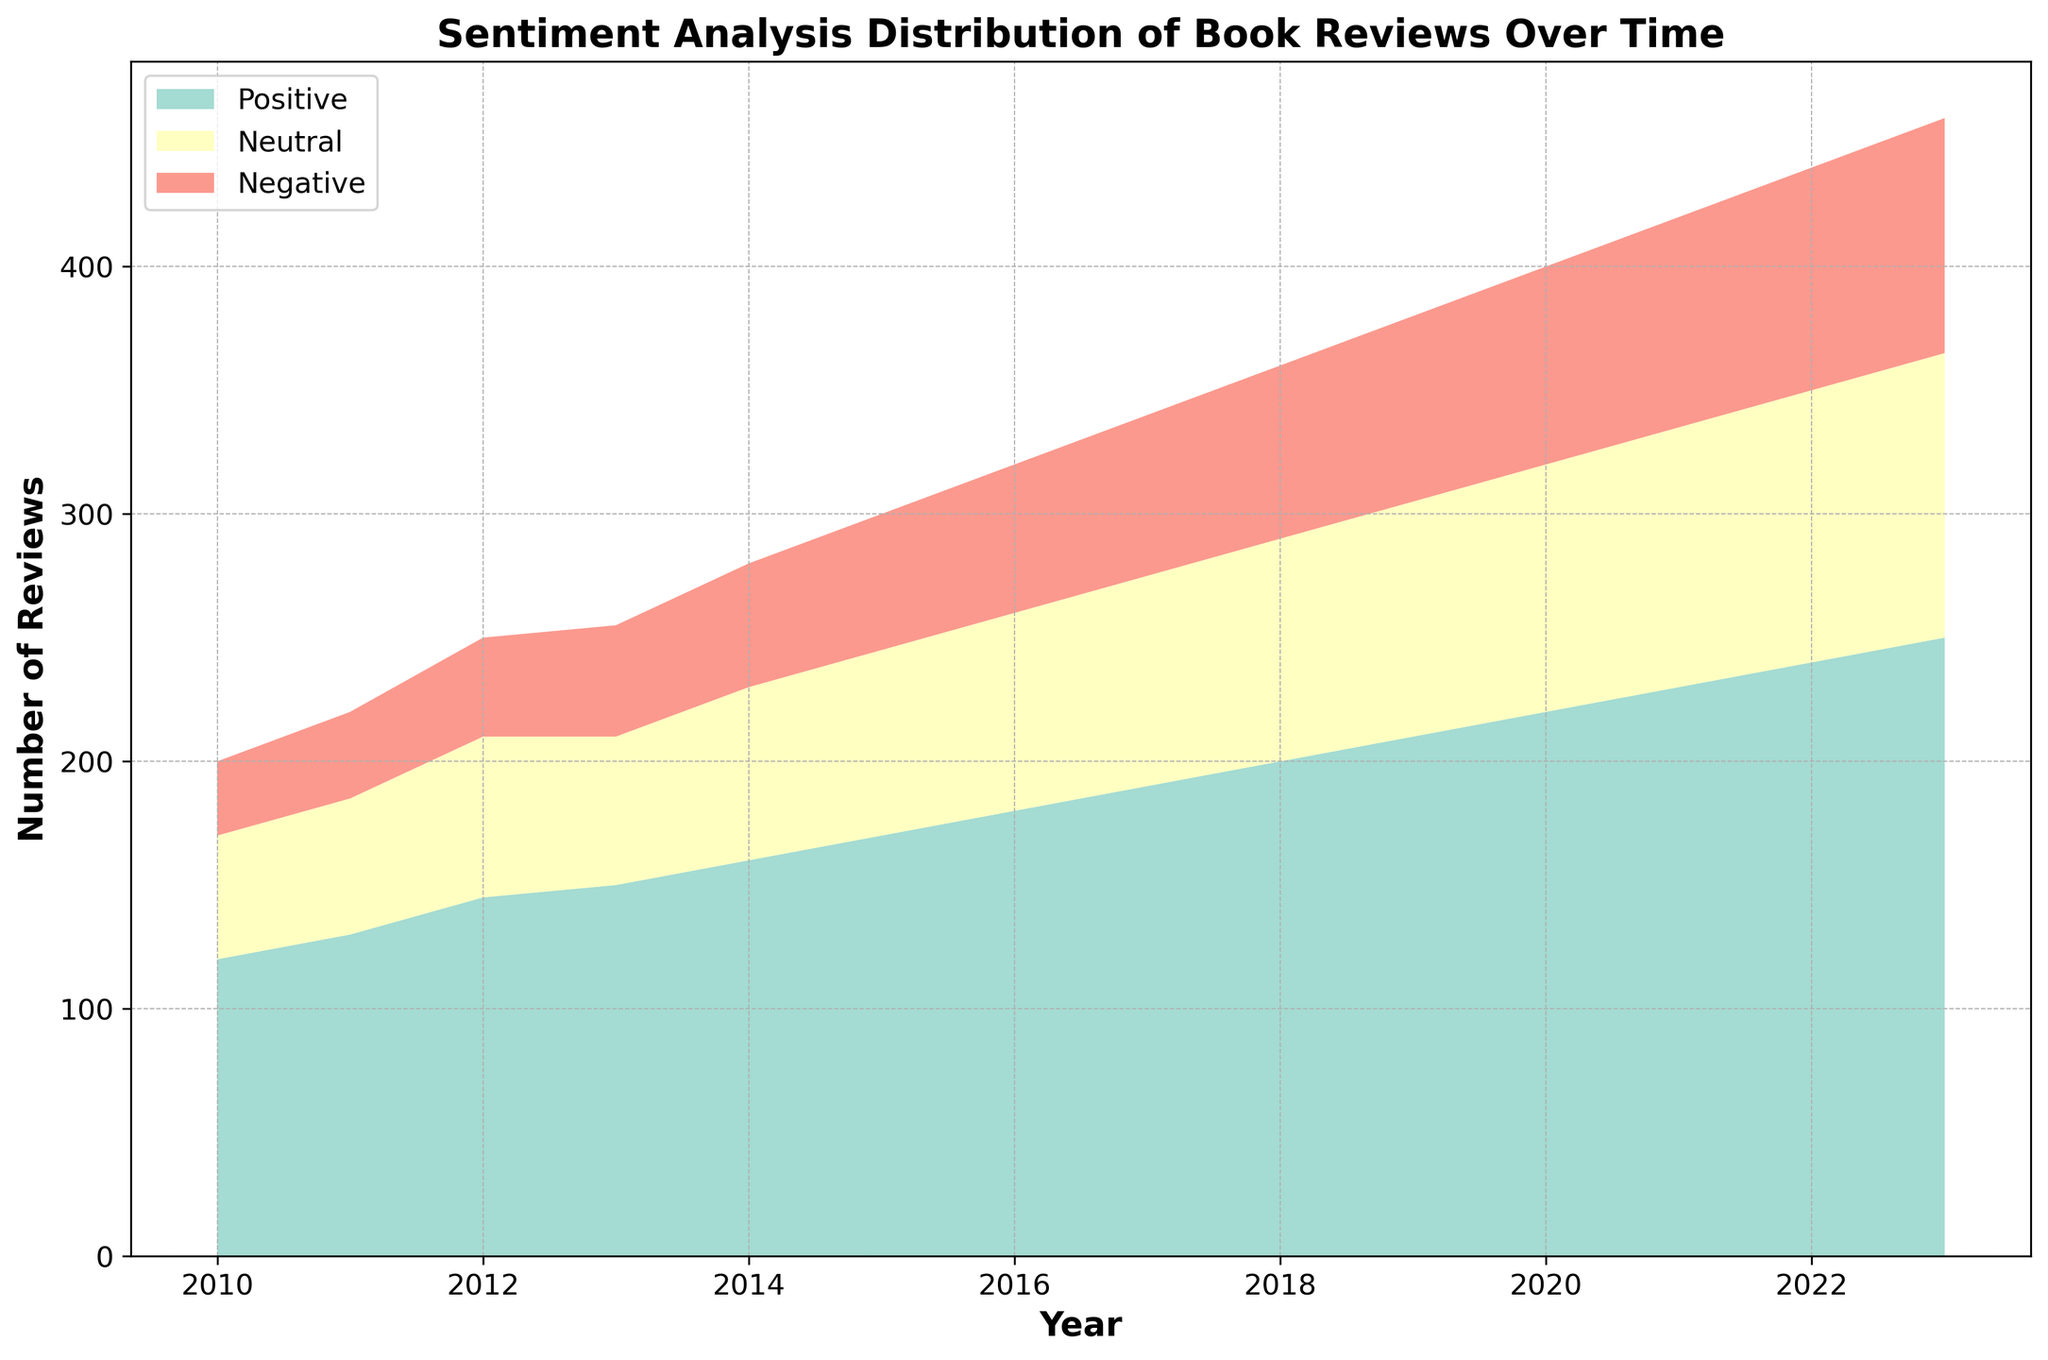What is the total number of reviews in 2023? Sum the positive, neutral, and negative reviews for 2023: 250 (positive) + 115 (neutral) + 95 (negative) = 460.
Answer: 460 In which year was the number of positive reviews first greater than 200? Observe the graph and find the earliest year where the positive area exceeds 200 reviews; this occurs in 2018.
Answer: 2018 How do the number of neutral reviews compare between 2015 and 2021? Check the neutral areas corresponding to 2015 and 2021. In 2015, there are 75 neutral reviews, and in 2021, there are 105 neutral reviews. Hence, the number is greater in 2021 than in 2015.
Answer: Greater in 2021 Which year saw the largest increase in negative reviews compared to the previous year? Calculate the difference in negative reviews year-over-year: 
2011: 35-30 = 5,  
2012: 40-35 = 5,  
2013: 45-40 = 5,  
2014: 50-45 = 5,  
2015: 55-50 = 5,  
2016: 60-55 = 5,  
2017: 65-60 = 5,  
2018: 70-65 = 5,  
2019: 75-70 = 5,  
2020: 80-75 = 5,  
2021: 85-80 = 5,  
2022: 90-85 = 5,  
2023: 95-90 = 5.  
All increases are equal, hence no single year shows a larger increase than any other.
Answer: No single year What is the average number of positive reviews from 2010 to 2015? Sum the positive reviews from 2010 to 2015: (120 + 130 + 145 + 150 + 160 + 170) = 875. The number of years is 6, so the average is 875 / 6 ≈ 145.83.
Answer: 145.83 Which sentiment category had the least number of reviews overall in 2010? Compare the visual areas for 2010: Positive (120), Neutral (50), Negative (30). The negative category has the smallest area.
Answer: Negative From 2010 to 2023, which type of sentiment saw the greatest overall increase in the number of reviews? Calculate the increase for each sentiment:  
Positive: 250 - 120 = 130,  
Neutral: 115 - 50 = 65,  
Negative: 95 - 30 = 65.  
The positive sentiment saw the greatest increase.
Answer: Positive Are there any years where the number of neutral reviews decreased from the previous year? Analyze the neutral reviews year-by-year. Each year shows an increase or stays the same; no decrease is observed.
Answer: No How has the trend of negative reviews changed from 2010 to 2023? Observe the negative sentiment area from 2010 to 2023: it consistently rises each year, showing a steady increase in negative reviews.
Answer: Steady increase 